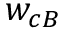<formula> <loc_0><loc_0><loc_500><loc_500>w _ { c B }</formula> 